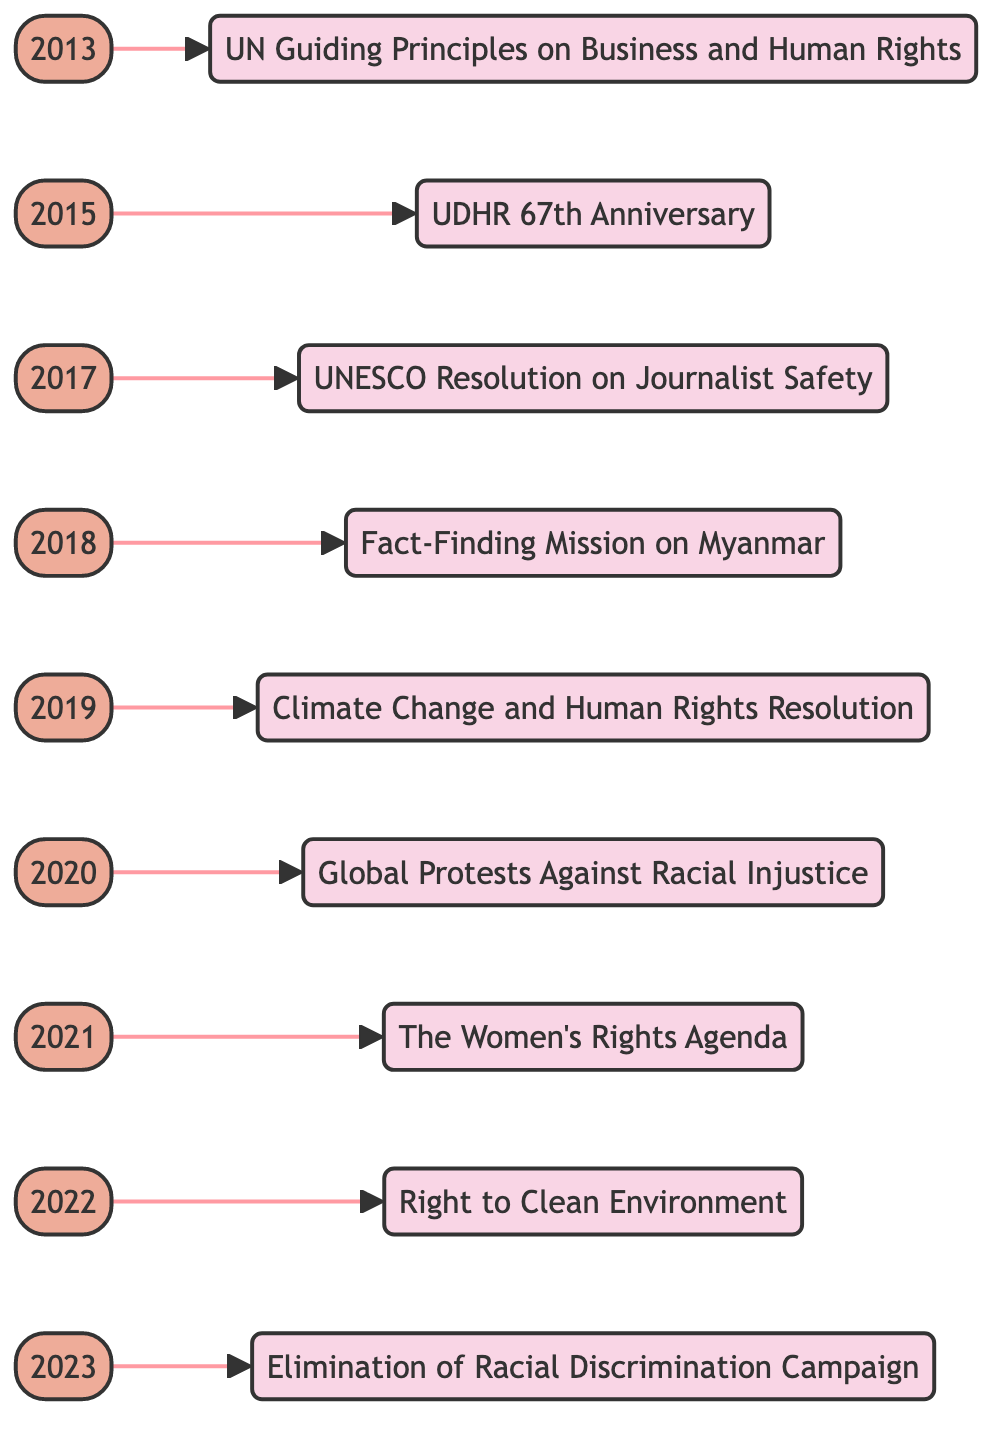What year was the UN Guiding Principles on Business and Human Rights adopted? The node labeled "2013" connects to the event "UN Guiding Principles on Business and Human Rights," indicating that this event occurred in that year
Answer: 2013 How many events are listed in the timeline? Counting all the event nodes, there are nine listed: one for each year from 2013 to 2023
Answer: 9 What is the event associated with the year 2021? The node labeled "2021" connects to the event "The Women's Rights Agenda," making this the event for that year
Answer: The Women's Rights Agenda Which event follows the Climate Change and Human Rights Resolution? The node for "Climate Change and Human Rights Resolution" is connected to "Global Protests Against Racial Injustice," indicating that this event follows it
Answer: Global Protests Against Racial Injustice What significant human rights event occurred in 2022? The node linked to "2022" represents the event "Right to Clean Environment," revealing that this was the significant event that year
Answer: Right to Clean Environment Which two events were recognized in consecutive years, 2019 and 2020? From the year nodes, 2019 connects to the "Climate Change and Human Rights Resolution," and 2020 connects to "Global Protests Against Racial Injustice," indicating these two events occurred back-to-back in those years
Answer: Climate Change and Human Rights Resolution, Global Protests Against Racial Injustice What is the primary focus of the 2023 event? The node for "2023" is connected to "Elimination of Racial Discrimination Campaign," highlighting that the focus for this year is on combating racial discrimination
Answer: Elimination of Racial Discrimination Campaign How does the 2018 event relate to the event in 2017? The 2017 event "UNESCO Resolution on Journalist Safety" leads to the 2018 event "Fact-Finding Mission on Myanmar," showing a progression from the protection of journalists to the investigation of human rights abuses
Answer: Progression from journalist safety to investigation of human rights abuses Which event marks the celebration of the Universal Declaration on Human Rights? The event marked in "2015" relates to the "UDHR 67th Anniversary," indicating this is when the celebration occurred
Answer: UDHR 67th Anniversary 